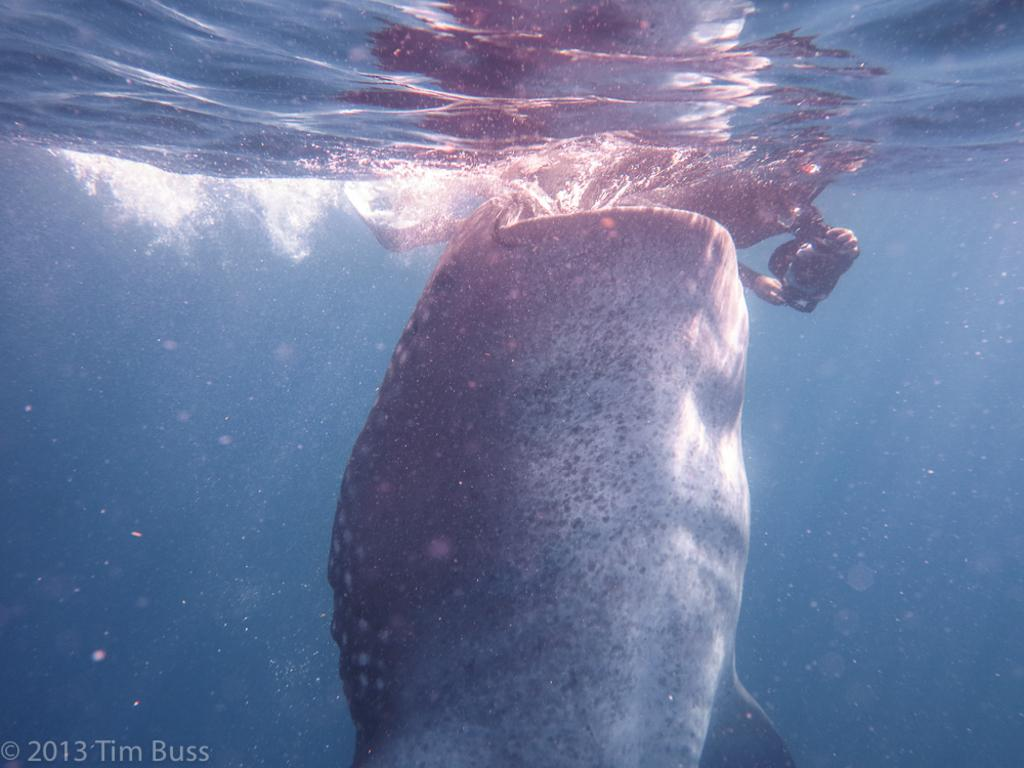What type of animal is present in the image? There is a mammal in the image. Can you describe the position of the mammal in the image? The lower body of the mammal is underwater. How many wars are depicted in the image? There are no wars depicted in the image; it features a mammal with its lower body underwater. 